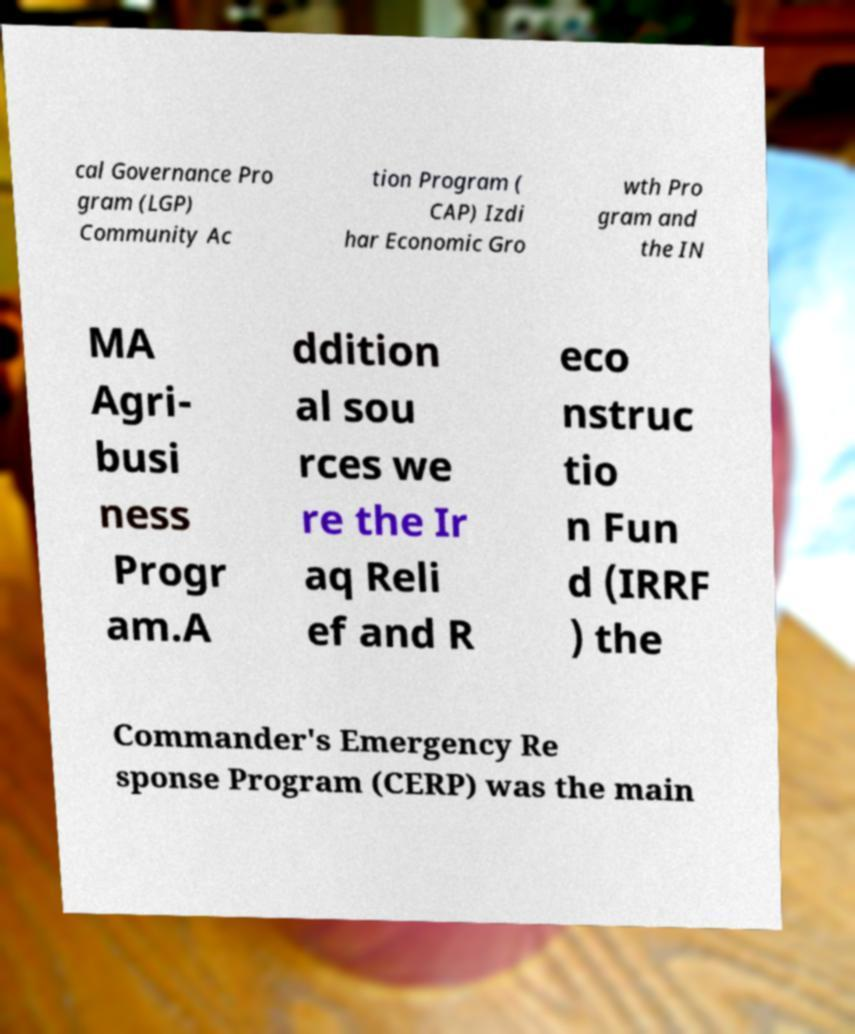Could you extract and type out the text from this image? cal Governance Pro gram (LGP) Community Ac tion Program ( CAP) Izdi har Economic Gro wth Pro gram and the IN MA Agri- busi ness Progr am.A ddition al sou rces we re the Ir aq Reli ef and R eco nstruc tio n Fun d (IRRF ) the Commander's Emergency Re sponse Program (CERP) was the main 